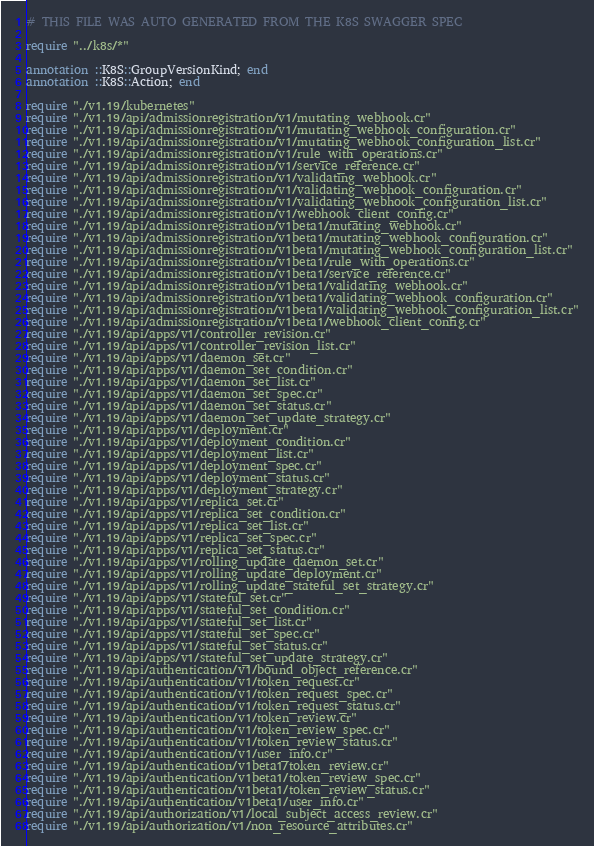Convert code to text. <code><loc_0><loc_0><loc_500><loc_500><_Crystal_># THIS FILE WAS AUTO GENERATED FROM THE K8S SWAGGER SPEC

require "../k8s/*"

annotation ::K8S::GroupVersionKind; end
annotation ::K8S::Action; end

require "./v1.19/kubernetes"
require "./v1.19/api/admissionregistration/v1/mutating_webhook.cr"
require "./v1.19/api/admissionregistration/v1/mutating_webhook_configuration.cr"
require "./v1.19/api/admissionregistration/v1/mutating_webhook_configuration_list.cr"
require "./v1.19/api/admissionregistration/v1/rule_with_operations.cr"
require "./v1.19/api/admissionregistration/v1/service_reference.cr"
require "./v1.19/api/admissionregistration/v1/validating_webhook.cr"
require "./v1.19/api/admissionregistration/v1/validating_webhook_configuration.cr"
require "./v1.19/api/admissionregistration/v1/validating_webhook_configuration_list.cr"
require "./v1.19/api/admissionregistration/v1/webhook_client_config.cr"
require "./v1.19/api/admissionregistration/v1beta1/mutating_webhook.cr"
require "./v1.19/api/admissionregistration/v1beta1/mutating_webhook_configuration.cr"
require "./v1.19/api/admissionregistration/v1beta1/mutating_webhook_configuration_list.cr"
require "./v1.19/api/admissionregistration/v1beta1/rule_with_operations.cr"
require "./v1.19/api/admissionregistration/v1beta1/service_reference.cr"
require "./v1.19/api/admissionregistration/v1beta1/validating_webhook.cr"
require "./v1.19/api/admissionregistration/v1beta1/validating_webhook_configuration.cr"
require "./v1.19/api/admissionregistration/v1beta1/validating_webhook_configuration_list.cr"
require "./v1.19/api/admissionregistration/v1beta1/webhook_client_config.cr"
require "./v1.19/api/apps/v1/controller_revision.cr"
require "./v1.19/api/apps/v1/controller_revision_list.cr"
require "./v1.19/api/apps/v1/daemon_set.cr"
require "./v1.19/api/apps/v1/daemon_set_condition.cr"
require "./v1.19/api/apps/v1/daemon_set_list.cr"
require "./v1.19/api/apps/v1/daemon_set_spec.cr"
require "./v1.19/api/apps/v1/daemon_set_status.cr"
require "./v1.19/api/apps/v1/daemon_set_update_strategy.cr"
require "./v1.19/api/apps/v1/deployment.cr"
require "./v1.19/api/apps/v1/deployment_condition.cr"
require "./v1.19/api/apps/v1/deployment_list.cr"
require "./v1.19/api/apps/v1/deployment_spec.cr"
require "./v1.19/api/apps/v1/deployment_status.cr"
require "./v1.19/api/apps/v1/deployment_strategy.cr"
require "./v1.19/api/apps/v1/replica_set.cr"
require "./v1.19/api/apps/v1/replica_set_condition.cr"
require "./v1.19/api/apps/v1/replica_set_list.cr"
require "./v1.19/api/apps/v1/replica_set_spec.cr"
require "./v1.19/api/apps/v1/replica_set_status.cr"
require "./v1.19/api/apps/v1/rolling_update_daemon_set.cr"
require "./v1.19/api/apps/v1/rolling_update_deployment.cr"
require "./v1.19/api/apps/v1/rolling_update_stateful_set_strategy.cr"
require "./v1.19/api/apps/v1/stateful_set.cr"
require "./v1.19/api/apps/v1/stateful_set_condition.cr"
require "./v1.19/api/apps/v1/stateful_set_list.cr"
require "./v1.19/api/apps/v1/stateful_set_spec.cr"
require "./v1.19/api/apps/v1/stateful_set_status.cr"
require "./v1.19/api/apps/v1/stateful_set_update_strategy.cr"
require "./v1.19/api/authentication/v1/bound_object_reference.cr"
require "./v1.19/api/authentication/v1/token_request.cr"
require "./v1.19/api/authentication/v1/token_request_spec.cr"
require "./v1.19/api/authentication/v1/token_request_status.cr"
require "./v1.19/api/authentication/v1/token_review.cr"
require "./v1.19/api/authentication/v1/token_review_spec.cr"
require "./v1.19/api/authentication/v1/token_review_status.cr"
require "./v1.19/api/authentication/v1/user_info.cr"
require "./v1.19/api/authentication/v1beta1/token_review.cr"
require "./v1.19/api/authentication/v1beta1/token_review_spec.cr"
require "./v1.19/api/authentication/v1beta1/token_review_status.cr"
require "./v1.19/api/authentication/v1beta1/user_info.cr"
require "./v1.19/api/authorization/v1/local_subject_access_review.cr"
require "./v1.19/api/authorization/v1/non_resource_attributes.cr"</code> 